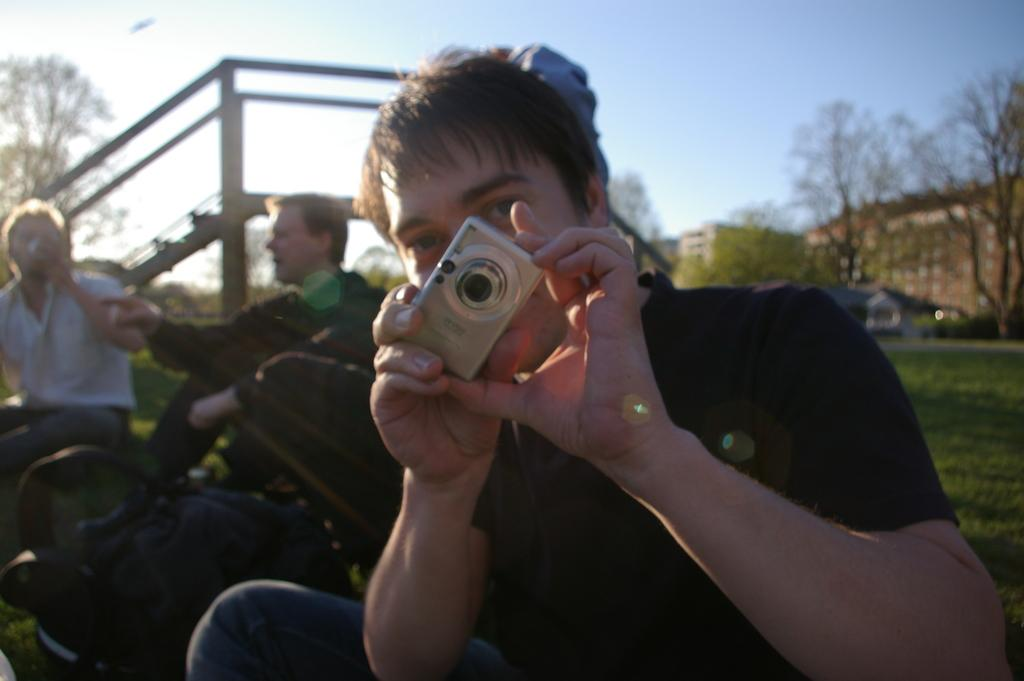How many people are sitting in the garden in the image? There are three people sitting in the garden in the image. What is the man in the front holding? The man in the front is holding a camera. What can be seen at the back side of the image? There is a building and a tree visible at the back side of the image. What is visible in the sky in the image? The sky is visible in the image. Are there any dinosaurs visible in the image? No, there are no dinosaurs present in the image. Can you tell me what type of bike the people are riding in the image? There is no bike visible in the image; the people are sitting in the garden. 